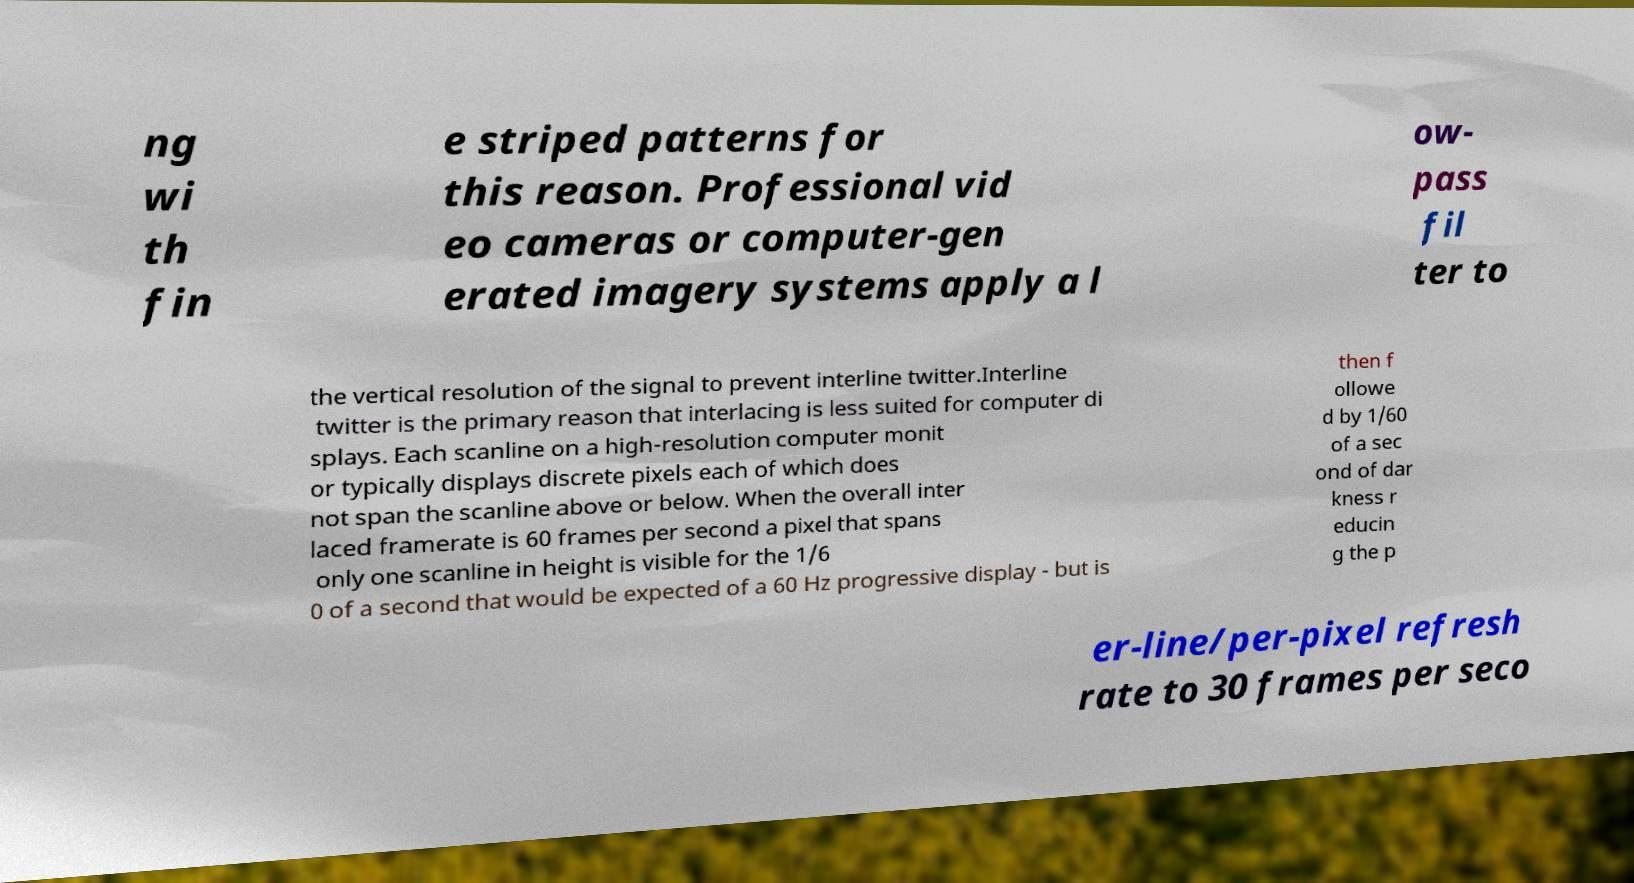Can you read and provide the text displayed in the image?This photo seems to have some interesting text. Can you extract and type it out for me? ng wi th fin e striped patterns for this reason. Professional vid eo cameras or computer-gen erated imagery systems apply a l ow- pass fil ter to the vertical resolution of the signal to prevent interline twitter.Interline twitter is the primary reason that interlacing is less suited for computer di splays. Each scanline on a high-resolution computer monit or typically displays discrete pixels each of which does not span the scanline above or below. When the overall inter laced framerate is 60 frames per second a pixel that spans only one scanline in height is visible for the 1/6 0 of a second that would be expected of a 60 Hz progressive display - but is then f ollowe d by 1/60 of a sec ond of dar kness r educin g the p er-line/per-pixel refresh rate to 30 frames per seco 